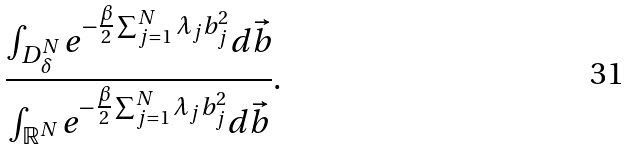<formula> <loc_0><loc_0><loc_500><loc_500>\frac { \int _ { D _ { \delta } ^ { N } } e ^ { - \frac { \beta } { 2 } \sum _ { j = 1 } ^ { N } \lambda _ { j } b _ { j } ^ { 2 } } d \vec { b } } { \int _ { \mathbb { R } ^ { N } } e ^ { - \frac { \beta } { 2 } \sum _ { j = 1 } ^ { N } \lambda _ { j } b _ { j } ^ { 2 } } d \vec { b } } .</formula> 